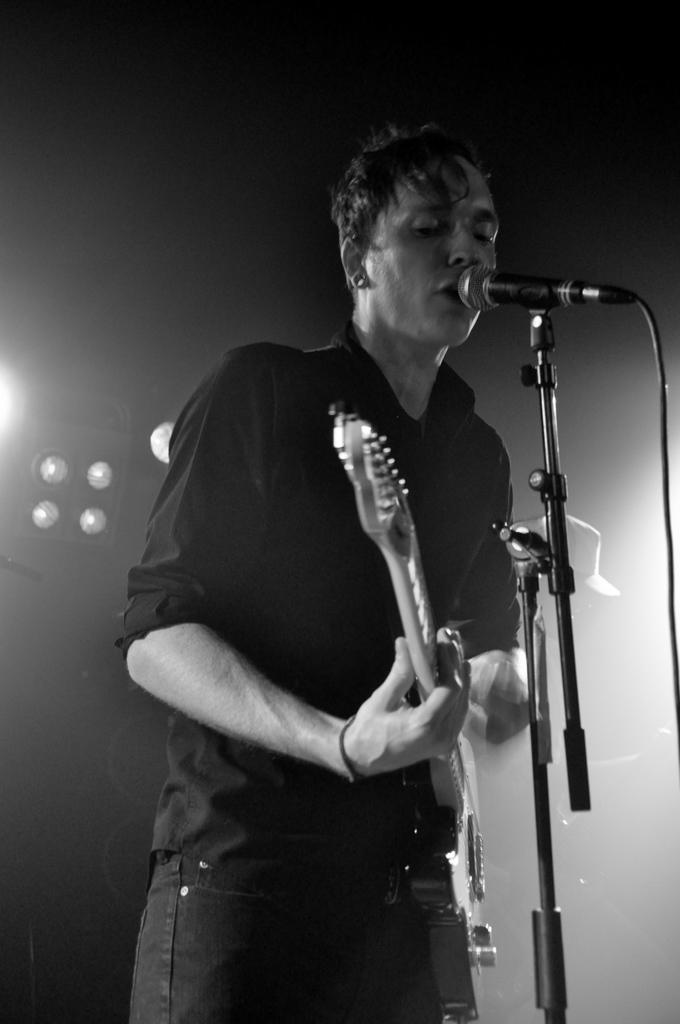Who is the main subject in the image? There is a man in the image. What is the man wearing? The man is wearing a black shirt. What is the man doing in the image? The man is standing and playing a guitar. What is in front of the man? There is a microphone in front of the man. What can be seen in the left corner of the image? There are lights in the left corner of the image. How many cows are visible in the image? There are no cows present in the image. What finger is the man using to play the guitar in the image? The image does not show which finger the man is using to play the guitar. 